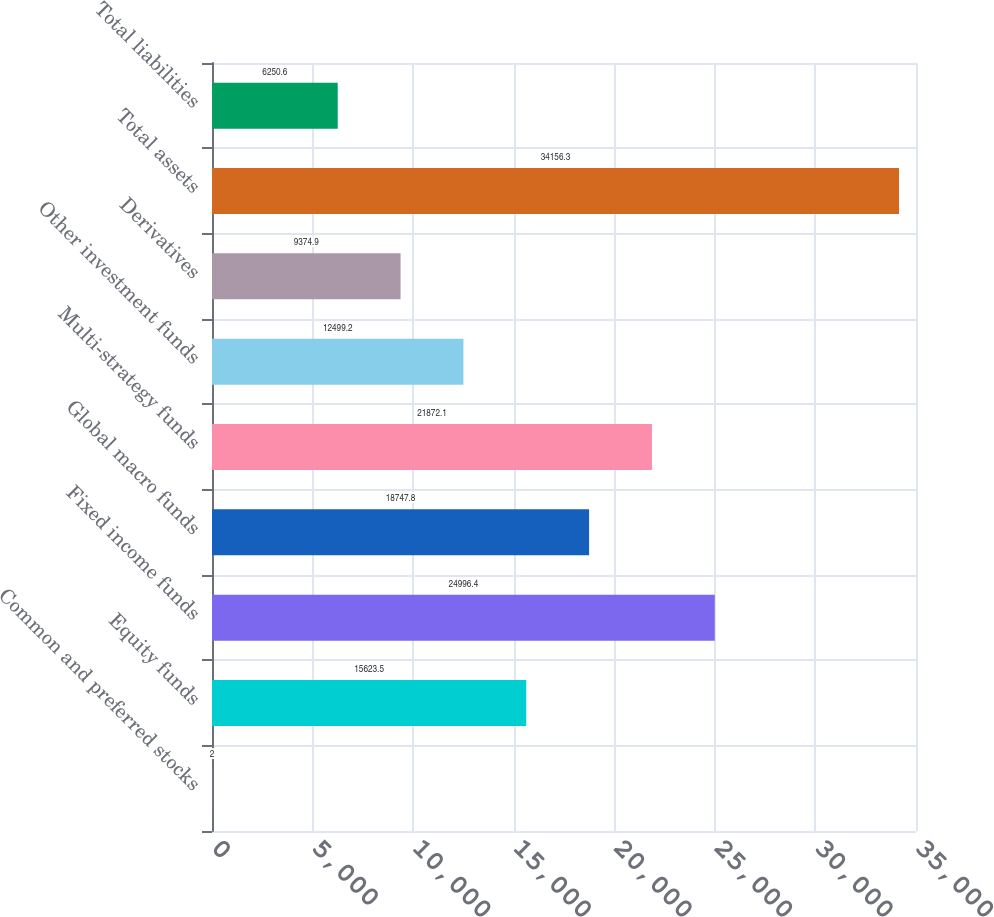<chart> <loc_0><loc_0><loc_500><loc_500><bar_chart><fcel>Common and preferred stocks<fcel>Equity funds<fcel>Fixed income funds<fcel>Global macro funds<fcel>Multi-strategy funds<fcel>Other investment funds<fcel>Derivatives<fcel>Total assets<fcel>Total liabilities<nl><fcel>2<fcel>15623.5<fcel>24996.4<fcel>18747.8<fcel>21872.1<fcel>12499.2<fcel>9374.9<fcel>34156.3<fcel>6250.6<nl></chart> 